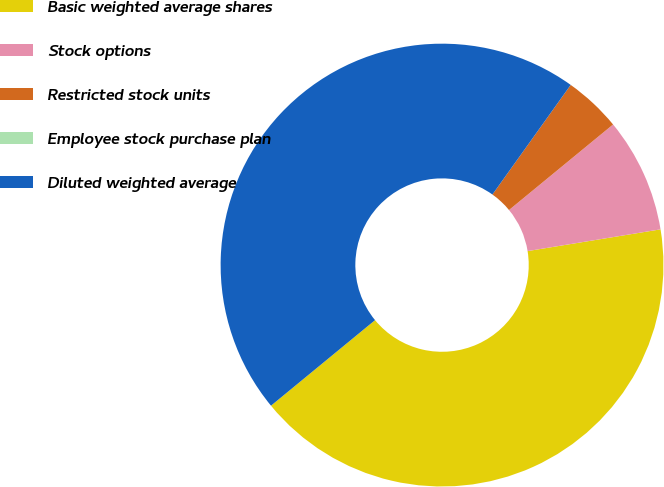Convert chart to OTSL. <chart><loc_0><loc_0><loc_500><loc_500><pie_chart><fcel>Basic weighted average shares<fcel>Stock options<fcel>Restricted stock units<fcel>Employee stock purchase plan<fcel>Diluted weighted average<nl><fcel>41.63%<fcel>8.37%<fcel>4.18%<fcel>0.0%<fcel>45.82%<nl></chart> 